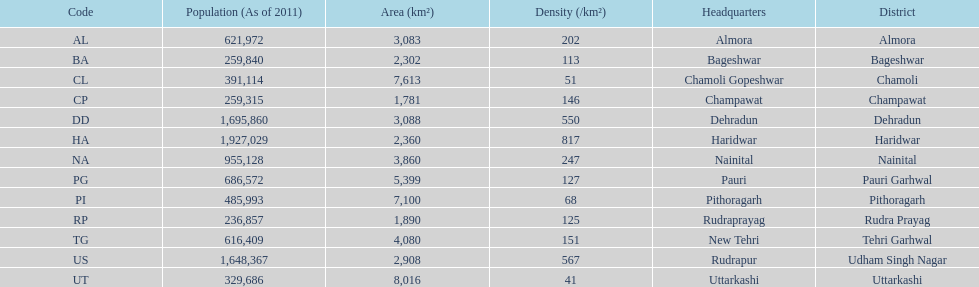What is the next most populous district after haridwar? Dehradun. 